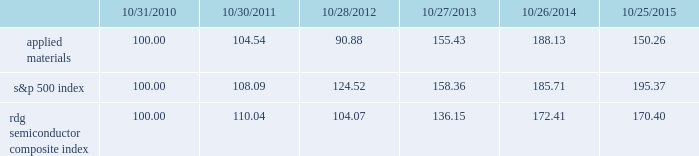Performance graph the performance graph below shows the five-year cumulative total stockholder return on applied common stock during the period from october 31 , 2010 through october 25 , 2015 .
This is compared with the cumulative total return of the standard & poor 2019s 500 stock index and the rdg semiconductor composite index over the same period .
The comparison assumes $ 100 was invested on october 31 , 2010 in applied common stock and in each of the foregoing indices and assumes reinvestment of dividends , if any .
Dollar amounts in the graph are rounded to the nearest whole dollar .
The performance shown in the graph represents past performance and should not be considered an indication of future performance .
Comparison of 5 year cumulative total return* among applied materials , inc. , the s&p 500 index and the rdg semiconductor composite index *assumes $ 100 invested on 10/31/10 in stock or index , including reinvestment of dividends .
Indexes calculated on month-end basis .
201cs&p 201d is a registered trademark of standard & poor 2019s financial services llc , a subsidiary of the mcgraw-hill companies , inc. .
Dividends during each of fiscal 2015 and 2014 , applied's board of directors declared four quarterly cash dividends of $ 0.10 per share .
During fiscal 2013 , applied 2019s board of directors declared three quarterly cash dividends of $ 0.10 per share and one quarterly cash dividend of $ 0.09 per share .
Dividends paid during fiscal 2015 , 2014 and 2013 amounted to $ 487 million , $ 485 million and $ 456 million , respectively .
Applied currently anticipates that cash dividends will continue to be paid on a quarterly basis , although the declaration of any future cash dividend is at the discretion of the board of directors and will depend on applied 2019s financial condition , results of operations , capital requirements , business conditions and other factors , as well as a determination by the board of directors that cash dividends are in the best interests of applied 2019s stockholders .
104 136 10/31/10 10/30/11 10/28/12 10/27/13 10/26/14 10/25/15 applied materials , inc .
S&p 500 rdg semiconductor composite .
How many outstanding shares received dividends in 2013 , ( in millions ) ? 
Computations: (487 / ((0.10 * 3) + 0.09))
Answer: 1248.71795. 